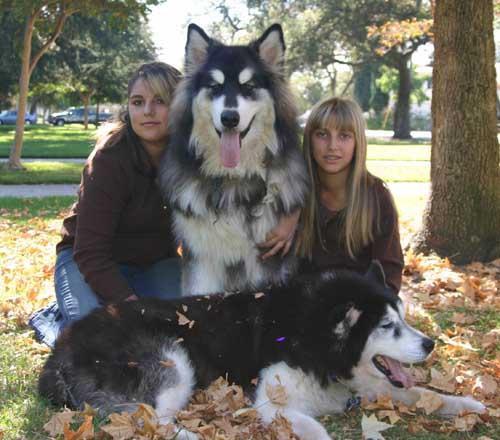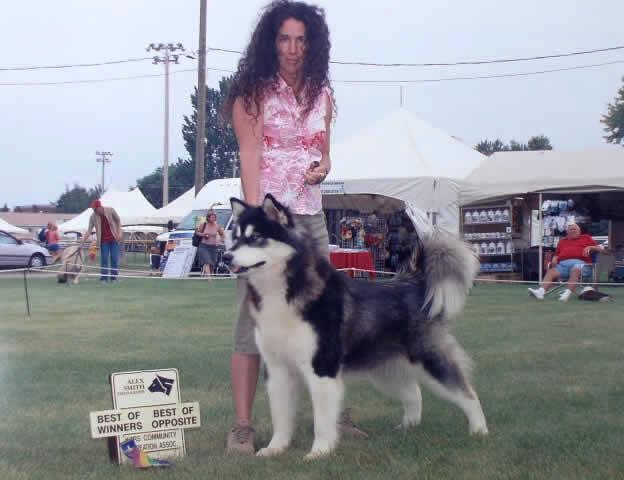The first image is the image on the left, the second image is the image on the right. Analyze the images presented: Is the assertion "The left and right image contains the same number of dogs." valid? Answer yes or no. No. The first image is the image on the left, the second image is the image on the right. For the images shown, is this caption "One image shows a woman standing behind a dog standing in profile turned leftward, and a sign with a prize ribbon is upright on the ground in front of the dog." true? Answer yes or no. Yes. 